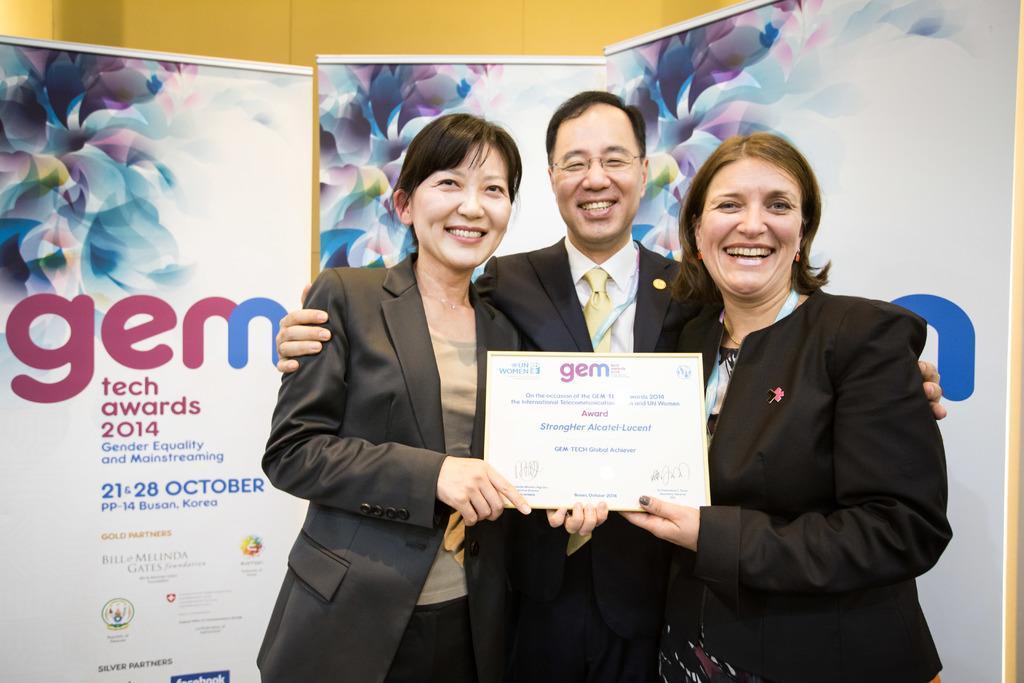Could you give a brief overview of what you see in this image? In this image, we can see three persons in front of banners. These three persons are standing and wearing clothes. There are two persons holding an award with their hands. 